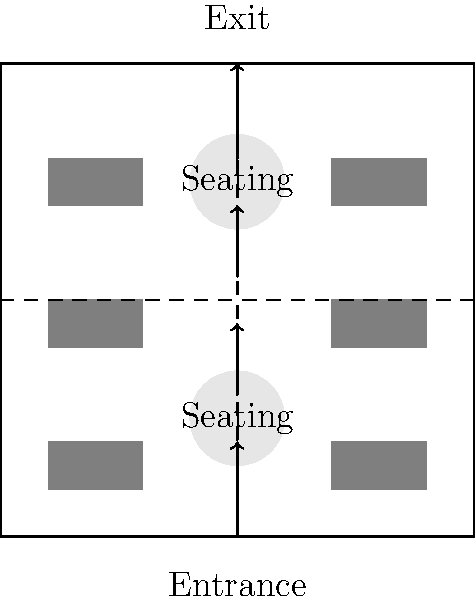In the given food truck park layout, what topology concept can be applied to optimize customer flow and minimize congestion? Consider the arrangement of food trucks, seating areas, and walkways. To optimize customer flow and minimize congestion in the food truck park, we can apply the concept of a "continuous deformation" from topology. Here's a step-by-step explanation:

1. Observe the current layout:
   - 6 food trucks arranged in two columns
   - 2 central seating areas
   - Main walkways forming a cross shape

2. Apply continuous deformation:
   - Imagine the layout as a flexible surface that can be stretched and bent without tearing or gluing.
   - The goal is to create a layout that allows for smooth customer movement without creating bottlenecks.

3. Optimize the layout:
   - Transform the linear arrangement of food trucks into a circular or semi-circular layout.
   - This creates a "loop" topology, where customers can move in a continuous flow.

4. Consider the homotopy concept:
   - The transformation from the current layout to the optimized layout can be seen as a homotopy.
   - Homotopy allows for continuous deformation between two topological spaces.

5. Improve customer flow:
   - The circular arrangement allows customers to move freely between food trucks without backtracking.
   - This reduces congestion by eliminating dead-ends and creating multiple paths.

6. Centralize seating:
   - Move seating areas to the center of the circular arrangement.
   - This creates a natural "hub" for customers to gather and disperse.

7. Optimize entrance and exit:
   - Position the entrance and exit at opposite ends of the circular layout.
   - This creates a natural flow direction and prevents congestion at a single point.

By applying these topological concepts, we create a layout that is homeomorphic to the original but optimized for customer flow and reduced congestion.
Answer: Continuous deformation and homotopy 